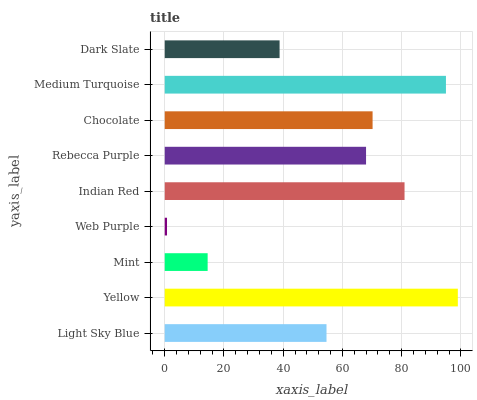Is Web Purple the minimum?
Answer yes or no. Yes. Is Yellow the maximum?
Answer yes or no. Yes. Is Mint the minimum?
Answer yes or no. No. Is Mint the maximum?
Answer yes or no. No. Is Yellow greater than Mint?
Answer yes or no. Yes. Is Mint less than Yellow?
Answer yes or no. Yes. Is Mint greater than Yellow?
Answer yes or no. No. Is Yellow less than Mint?
Answer yes or no. No. Is Rebecca Purple the high median?
Answer yes or no. Yes. Is Rebecca Purple the low median?
Answer yes or no. Yes. Is Medium Turquoise the high median?
Answer yes or no. No. Is Web Purple the low median?
Answer yes or no. No. 